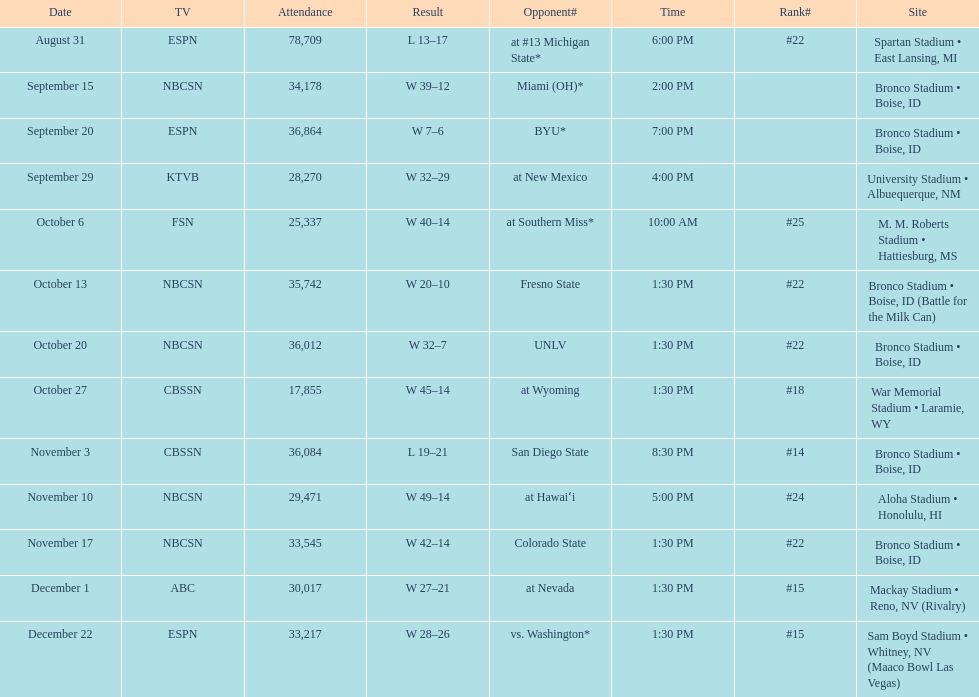What was the most consecutive wins for the team shown in the season? 7. 